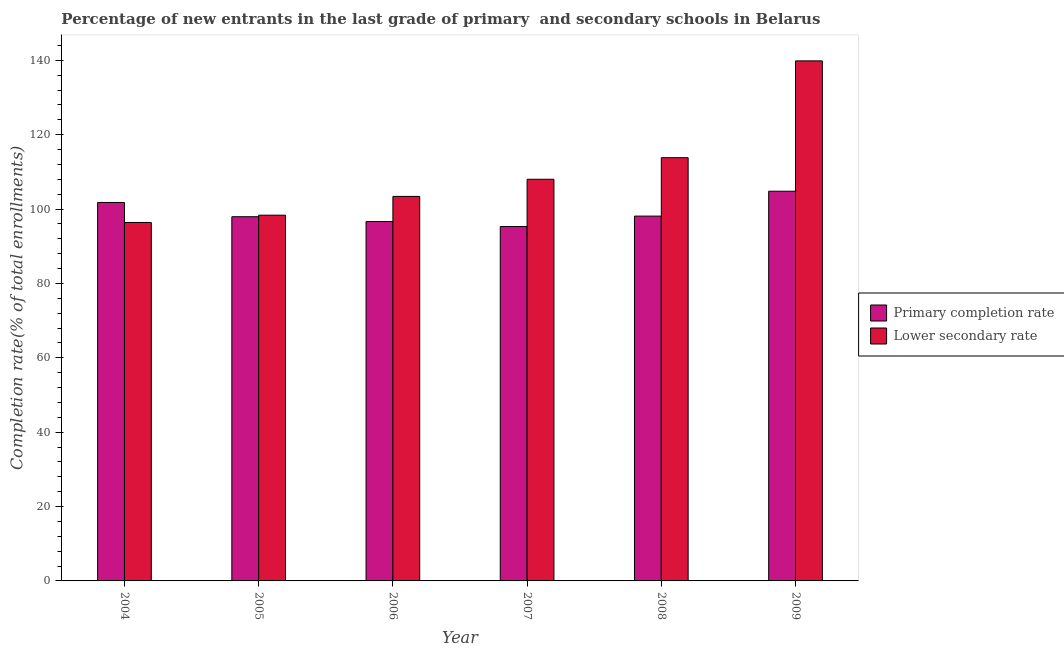Are the number of bars per tick equal to the number of legend labels?
Give a very brief answer. Yes. Are the number of bars on each tick of the X-axis equal?
Offer a very short reply. Yes. How many bars are there on the 1st tick from the left?
Your response must be concise. 2. How many bars are there on the 1st tick from the right?
Offer a very short reply. 2. What is the completion rate in secondary schools in 2007?
Provide a short and direct response. 108.02. Across all years, what is the maximum completion rate in secondary schools?
Your response must be concise. 139.86. Across all years, what is the minimum completion rate in primary schools?
Ensure brevity in your answer.  95.31. In which year was the completion rate in primary schools maximum?
Ensure brevity in your answer.  2009. In which year was the completion rate in secondary schools minimum?
Give a very brief answer. 2004. What is the total completion rate in secondary schools in the graph?
Offer a terse response. 659.89. What is the difference between the completion rate in primary schools in 2004 and that in 2006?
Offer a very short reply. 5.13. What is the difference between the completion rate in primary schools in 2005 and the completion rate in secondary schools in 2008?
Offer a terse response. -0.17. What is the average completion rate in primary schools per year?
Your response must be concise. 99.1. In the year 2006, what is the difference between the completion rate in primary schools and completion rate in secondary schools?
Offer a very short reply. 0. What is the ratio of the completion rate in secondary schools in 2004 to that in 2006?
Your answer should be very brief. 0.93. Is the completion rate in secondary schools in 2004 less than that in 2005?
Make the answer very short. Yes. What is the difference between the highest and the second highest completion rate in secondary schools?
Your answer should be compact. 26.04. What is the difference between the highest and the lowest completion rate in secondary schools?
Keep it short and to the point. 43.46. In how many years, is the completion rate in primary schools greater than the average completion rate in primary schools taken over all years?
Provide a succinct answer. 2. Is the sum of the completion rate in primary schools in 2004 and 2006 greater than the maximum completion rate in secondary schools across all years?
Provide a short and direct response. Yes. What does the 1st bar from the left in 2007 represents?
Offer a terse response. Primary completion rate. What does the 1st bar from the right in 2008 represents?
Offer a very short reply. Lower secondary rate. How many years are there in the graph?
Make the answer very short. 6. Are the values on the major ticks of Y-axis written in scientific E-notation?
Offer a terse response. No. Does the graph contain grids?
Your answer should be compact. No. Where does the legend appear in the graph?
Make the answer very short. Center right. What is the title of the graph?
Provide a succinct answer. Percentage of new entrants in the last grade of primary  and secondary schools in Belarus. Does "Time to export" appear as one of the legend labels in the graph?
Ensure brevity in your answer.  No. What is the label or title of the X-axis?
Provide a short and direct response. Year. What is the label or title of the Y-axis?
Your response must be concise. Completion rate(% of total enrollments). What is the Completion rate(% of total enrollments) of Primary completion rate in 2004?
Your response must be concise. 101.79. What is the Completion rate(% of total enrollments) in Lower secondary rate in 2004?
Provide a succinct answer. 96.4. What is the Completion rate(% of total enrollments) in Primary completion rate in 2005?
Provide a short and direct response. 97.95. What is the Completion rate(% of total enrollments) in Lower secondary rate in 2005?
Offer a very short reply. 98.36. What is the Completion rate(% of total enrollments) of Primary completion rate in 2006?
Provide a succinct answer. 96.65. What is the Completion rate(% of total enrollments) in Lower secondary rate in 2006?
Your response must be concise. 103.42. What is the Completion rate(% of total enrollments) of Primary completion rate in 2007?
Your response must be concise. 95.31. What is the Completion rate(% of total enrollments) in Lower secondary rate in 2007?
Keep it short and to the point. 108.02. What is the Completion rate(% of total enrollments) of Primary completion rate in 2008?
Provide a short and direct response. 98.12. What is the Completion rate(% of total enrollments) in Lower secondary rate in 2008?
Your answer should be very brief. 113.82. What is the Completion rate(% of total enrollments) of Primary completion rate in 2009?
Your response must be concise. 104.81. What is the Completion rate(% of total enrollments) of Lower secondary rate in 2009?
Offer a very short reply. 139.86. Across all years, what is the maximum Completion rate(% of total enrollments) in Primary completion rate?
Your answer should be very brief. 104.81. Across all years, what is the maximum Completion rate(% of total enrollments) of Lower secondary rate?
Provide a succinct answer. 139.86. Across all years, what is the minimum Completion rate(% of total enrollments) in Primary completion rate?
Give a very brief answer. 95.31. Across all years, what is the minimum Completion rate(% of total enrollments) in Lower secondary rate?
Ensure brevity in your answer.  96.4. What is the total Completion rate(% of total enrollments) of Primary completion rate in the graph?
Make the answer very short. 594.62. What is the total Completion rate(% of total enrollments) in Lower secondary rate in the graph?
Your answer should be very brief. 659.89. What is the difference between the Completion rate(% of total enrollments) of Primary completion rate in 2004 and that in 2005?
Your answer should be very brief. 3.84. What is the difference between the Completion rate(% of total enrollments) of Lower secondary rate in 2004 and that in 2005?
Your answer should be very brief. -1.96. What is the difference between the Completion rate(% of total enrollments) in Primary completion rate in 2004 and that in 2006?
Provide a succinct answer. 5.13. What is the difference between the Completion rate(% of total enrollments) of Lower secondary rate in 2004 and that in 2006?
Make the answer very short. -7.01. What is the difference between the Completion rate(% of total enrollments) in Primary completion rate in 2004 and that in 2007?
Make the answer very short. 6.48. What is the difference between the Completion rate(% of total enrollments) in Lower secondary rate in 2004 and that in 2007?
Your answer should be very brief. -11.62. What is the difference between the Completion rate(% of total enrollments) of Primary completion rate in 2004 and that in 2008?
Provide a succinct answer. 3.67. What is the difference between the Completion rate(% of total enrollments) of Lower secondary rate in 2004 and that in 2008?
Your response must be concise. -17.42. What is the difference between the Completion rate(% of total enrollments) in Primary completion rate in 2004 and that in 2009?
Provide a short and direct response. -3.02. What is the difference between the Completion rate(% of total enrollments) of Lower secondary rate in 2004 and that in 2009?
Make the answer very short. -43.46. What is the difference between the Completion rate(% of total enrollments) in Primary completion rate in 2005 and that in 2006?
Your answer should be compact. 1.29. What is the difference between the Completion rate(% of total enrollments) in Lower secondary rate in 2005 and that in 2006?
Ensure brevity in your answer.  -5.05. What is the difference between the Completion rate(% of total enrollments) in Primary completion rate in 2005 and that in 2007?
Your answer should be compact. 2.64. What is the difference between the Completion rate(% of total enrollments) in Lower secondary rate in 2005 and that in 2007?
Your answer should be very brief. -9.66. What is the difference between the Completion rate(% of total enrollments) in Primary completion rate in 2005 and that in 2008?
Your answer should be compact. -0.17. What is the difference between the Completion rate(% of total enrollments) in Lower secondary rate in 2005 and that in 2008?
Offer a terse response. -15.46. What is the difference between the Completion rate(% of total enrollments) of Primary completion rate in 2005 and that in 2009?
Make the answer very short. -6.86. What is the difference between the Completion rate(% of total enrollments) in Lower secondary rate in 2005 and that in 2009?
Your response must be concise. -41.5. What is the difference between the Completion rate(% of total enrollments) in Primary completion rate in 2006 and that in 2007?
Your answer should be compact. 1.35. What is the difference between the Completion rate(% of total enrollments) of Lower secondary rate in 2006 and that in 2007?
Provide a succinct answer. -4.61. What is the difference between the Completion rate(% of total enrollments) of Primary completion rate in 2006 and that in 2008?
Provide a short and direct response. -1.46. What is the difference between the Completion rate(% of total enrollments) of Lower secondary rate in 2006 and that in 2008?
Keep it short and to the point. -10.41. What is the difference between the Completion rate(% of total enrollments) in Primary completion rate in 2006 and that in 2009?
Ensure brevity in your answer.  -8.15. What is the difference between the Completion rate(% of total enrollments) in Lower secondary rate in 2006 and that in 2009?
Keep it short and to the point. -36.45. What is the difference between the Completion rate(% of total enrollments) in Primary completion rate in 2007 and that in 2008?
Make the answer very short. -2.81. What is the difference between the Completion rate(% of total enrollments) in Lower secondary rate in 2007 and that in 2008?
Your answer should be compact. -5.8. What is the difference between the Completion rate(% of total enrollments) of Primary completion rate in 2007 and that in 2009?
Make the answer very short. -9.5. What is the difference between the Completion rate(% of total enrollments) in Lower secondary rate in 2007 and that in 2009?
Provide a succinct answer. -31.84. What is the difference between the Completion rate(% of total enrollments) in Primary completion rate in 2008 and that in 2009?
Offer a terse response. -6.69. What is the difference between the Completion rate(% of total enrollments) of Lower secondary rate in 2008 and that in 2009?
Make the answer very short. -26.04. What is the difference between the Completion rate(% of total enrollments) in Primary completion rate in 2004 and the Completion rate(% of total enrollments) in Lower secondary rate in 2005?
Ensure brevity in your answer.  3.42. What is the difference between the Completion rate(% of total enrollments) of Primary completion rate in 2004 and the Completion rate(% of total enrollments) of Lower secondary rate in 2006?
Your response must be concise. -1.63. What is the difference between the Completion rate(% of total enrollments) of Primary completion rate in 2004 and the Completion rate(% of total enrollments) of Lower secondary rate in 2007?
Make the answer very short. -6.24. What is the difference between the Completion rate(% of total enrollments) in Primary completion rate in 2004 and the Completion rate(% of total enrollments) in Lower secondary rate in 2008?
Offer a terse response. -12.04. What is the difference between the Completion rate(% of total enrollments) in Primary completion rate in 2004 and the Completion rate(% of total enrollments) in Lower secondary rate in 2009?
Your answer should be compact. -38.08. What is the difference between the Completion rate(% of total enrollments) in Primary completion rate in 2005 and the Completion rate(% of total enrollments) in Lower secondary rate in 2006?
Provide a succinct answer. -5.47. What is the difference between the Completion rate(% of total enrollments) of Primary completion rate in 2005 and the Completion rate(% of total enrollments) of Lower secondary rate in 2007?
Provide a succinct answer. -10.08. What is the difference between the Completion rate(% of total enrollments) of Primary completion rate in 2005 and the Completion rate(% of total enrollments) of Lower secondary rate in 2008?
Provide a succinct answer. -15.88. What is the difference between the Completion rate(% of total enrollments) in Primary completion rate in 2005 and the Completion rate(% of total enrollments) in Lower secondary rate in 2009?
Offer a very short reply. -41.92. What is the difference between the Completion rate(% of total enrollments) in Primary completion rate in 2006 and the Completion rate(% of total enrollments) in Lower secondary rate in 2007?
Offer a terse response. -11.37. What is the difference between the Completion rate(% of total enrollments) of Primary completion rate in 2006 and the Completion rate(% of total enrollments) of Lower secondary rate in 2008?
Offer a very short reply. -17.17. What is the difference between the Completion rate(% of total enrollments) of Primary completion rate in 2006 and the Completion rate(% of total enrollments) of Lower secondary rate in 2009?
Offer a terse response. -43.21. What is the difference between the Completion rate(% of total enrollments) of Primary completion rate in 2007 and the Completion rate(% of total enrollments) of Lower secondary rate in 2008?
Give a very brief answer. -18.52. What is the difference between the Completion rate(% of total enrollments) of Primary completion rate in 2007 and the Completion rate(% of total enrollments) of Lower secondary rate in 2009?
Your answer should be very brief. -44.55. What is the difference between the Completion rate(% of total enrollments) of Primary completion rate in 2008 and the Completion rate(% of total enrollments) of Lower secondary rate in 2009?
Keep it short and to the point. -41.74. What is the average Completion rate(% of total enrollments) of Primary completion rate per year?
Keep it short and to the point. 99.1. What is the average Completion rate(% of total enrollments) in Lower secondary rate per year?
Your answer should be very brief. 109.98. In the year 2004, what is the difference between the Completion rate(% of total enrollments) of Primary completion rate and Completion rate(% of total enrollments) of Lower secondary rate?
Keep it short and to the point. 5.38. In the year 2005, what is the difference between the Completion rate(% of total enrollments) in Primary completion rate and Completion rate(% of total enrollments) in Lower secondary rate?
Give a very brief answer. -0.42. In the year 2006, what is the difference between the Completion rate(% of total enrollments) in Primary completion rate and Completion rate(% of total enrollments) in Lower secondary rate?
Give a very brief answer. -6.76. In the year 2007, what is the difference between the Completion rate(% of total enrollments) of Primary completion rate and Completion rate(% of total enrollments) of Lower secondary rate?
Your answer should be compact. -12.72. In the year 2008, what is the difference between the Completion rate(% of total enrollments) in Primary completion rate and Completion rate(% of total enrollments) in Lower secondary rate?
Your answer should be compact. -15.71. In the year 2009, what is the difference between the Completion rate(% of total enrollments) in Primary completion rate and Completion rate(% of total enrollments) in Lower secondary rate?
Ensure brevity in your answer.  -35.05. What is the ratio of the Completion rate(% of total enrollments) of Primary completion rate in 2004 to that in 2005?
Make the answer very short. 1.04. What is the ratio of the Completion rate(% of total enrollments) in Primary completion rate in 2004 to that in 2006?
Offer a very short reply. 1.05. What is the ratio of the Completion rate(% of total enrollments) of Lower secondary rate in 2004 to that in 2006?
Provide a succinct answer. 0.93. What is the ratio of the Completion rate(% of total enrollments) of Primary completion rate in 2004 to that in 2007?
Provide a short and direct response. 1.07. What is the ratio of the Completion rate(% of total enrollments) in Lower secondary rate in 2004 to that in 2007?
Your response must be concise. 0.89. What is the ratio of the Completion rate(% of total enrollments) in Primary completion rate in 2004 to that in 2008?
Provide a succinct answer. 1.04. What is the ratio of the Completion rate(% of total enrollments) in Lower secondary rate in 2004 to that in 2008?
Provide a short and direct response. 0.85. What is the ratio of the Completion rate(% of total enrollments) in Primary completion rate in 2004 to that in 2009?
Give a very brief answer. 0.97. What is the ratio of the Completion rate(% of total enrollments) of Lower secondary rate in 2004 to that in 2009?
Offer a terse response. 0.69. What is the ratio of the Completion rate(% of total enrollments) in Primary completion rate in 2005 to that in 2006?
Offer a very short reply. 1.01. What is the ratio of the Completion rate(% of total enrollments) in Lower secondary rate in 2005 to that in 2006?
Provide a succinct answer. 0.95. What is the ratio of the Completion rate(% of total enrollments) of Primary completion rate in 2005 to that in 2007?
Your answer should be very brief. 1.03. What is the ratio of the Completion rate(% of total enrollments) in Lower secondary rate in 2005 to that in 2007?
Provide a short and direct response. 0.91. What is the ratio of the Completion rate(% of total enrollments) in Primary completion rate in 2005 to that in 2008?
Your answer should be compact. 1. What is the ratio of the Completion rate(% of total enrollments) in Lower secondary rate in 2005 to that in 2008?
Offer a terse response. 0.86. What is the ratio of the Completion rate(% of total enrollments) in Primary completion rate in 2005 to that in 2009?
Ensure brevity in your answer.  0.93. What is the ratio of the Completion rate(% of total enrollments) of Lower secondary rate in 2005 to that in 2009?
Your response must be concise. 0.7. What is the ratio of the Completion rate(% of total enrollments) in Primary completion rate in 2006 to that in 2007?
Your answer should be compact. 1.01. What is the ratio of the Completion rate(% of total enrollments) in Lower secondary rate in 2006 to that in 2007?
Your answer should be compact. 0.96. What is the ratio of the Completion rate(% of total enrollments) in Primary completion rate in 2006 to that in 2008?
Provide a succinct answer. 0.99. What is the ratio of the Completion rate(% of total enrollments) of Lower secondary rate in 2006 to that in 2008?
Your answer should be compact. 0.91. What is the ratio of the Completion rate(% of total enrollments) of Primary completion rate in 2006 to that in 2009?
Provide a short and direct response. 0.92. What is the ratio of the Completion rate(% of total enrollments) in Lower secondary rate in 2006 to that in 2009?
Offer a very short reply. 0.74. What is the ratio of the Completion rate(% of total enrollments) of Primary completion rate in 2007 to that in 2008?
Your response must be concise. 0.97. What is the ratio of the Completion rate(% of total enrollments) of Lower secondary rate in 2007 to that in 2008?
Keep it short and to the point. 0.95. What is the ratio of the Completion rate(% of total enrollments) in Primary completion rate in 2007 to that in 2009?
Your response must be concise. 0.91. What is the ratio of the Completion rate(% of total enrollments) in Lower secondary rate in 2007 to that in 2009?
Provide a short and direct response. 0.77. What is the ratio of the Completion rate(% of total enrollments) in Primary completion rate in 2008 to that in 2009?
Offer a very short reply. 0.94. What is the ratio of the Completion rate(% of total enrollments) of Lower secondary rate in 2008 to that in 2009?
Your answer should be very brief. 0.81. What is the difference between the highest and the second highest Completion rate(% of total enrollments) of Primary completion rate?
Offer a very short reply. 3.02. What is the difference between the highest and the second highest Completion rate(% of total enrollments) of Lower secondary rate?
Provide a succinct answer. 26.04. What is the difference between the highest and the lowest Completion rate(% of total enrollments) of Primary completion rate?
Your answer should be compact. 9.5. What is the difference between the highest and the lowest Completion rate(% of total enrollments) of Lower secondary rate?
Make the answer very short. 43.46. 